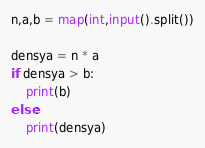<code> <loc_0><loc_0><loc_500><loc_500><_Python_>n,a,b = map(int,input().split())

densya = n * a
if densya > b:
    print(b)
else:
    print(densya)</code> 